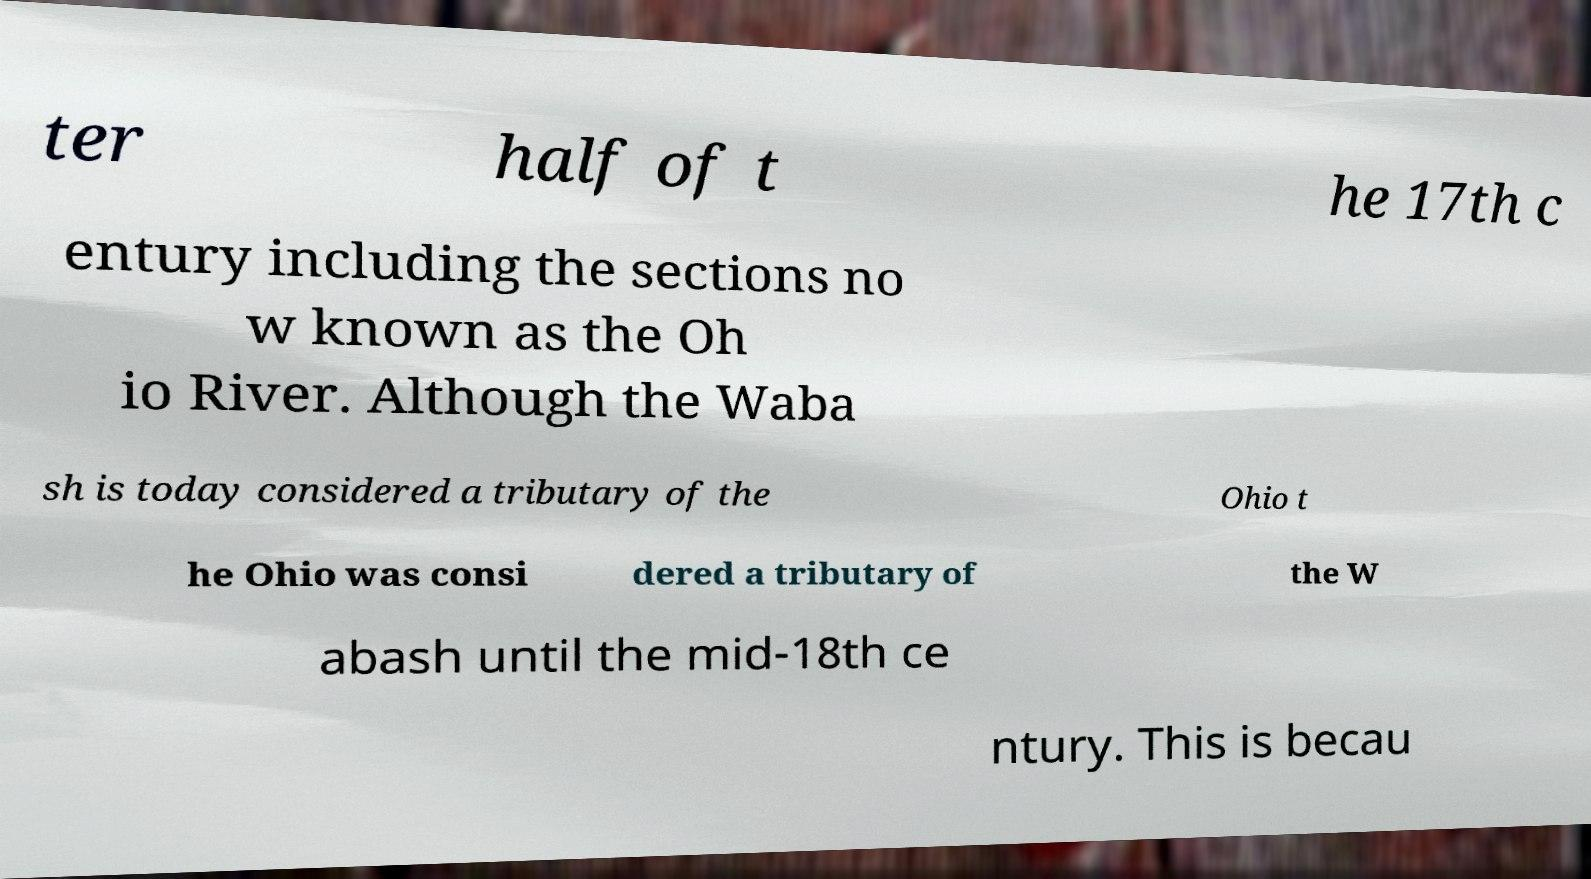There's text embedded in this image that I need extracted. Can you transcribe it verbatim? ter half of t he 17th c entury including the sections no w known as the Oh io River. Although the Waba sh is today considered a tributary of the Ohio t he Ohio was consi dered a tributary of the W abash until the mid-18th ce ntury. This is becau 